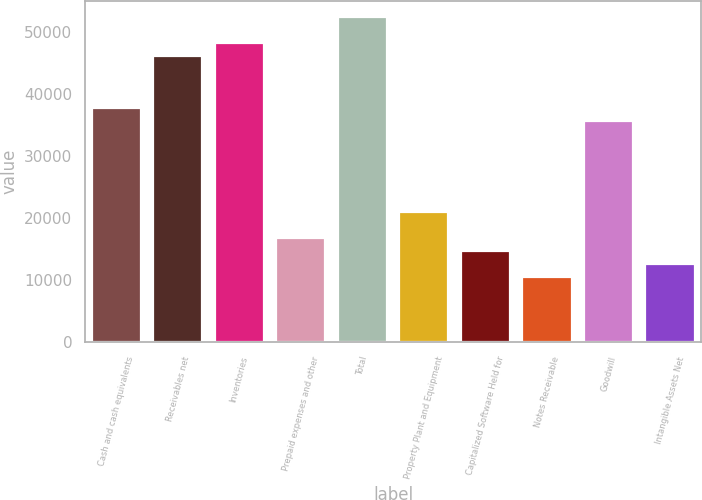<chart> <loc_0><loc_0><loc_500><loc_500><bar_chart><fcel>Cash and cash equivalents<fcel>Receivables net<fcel>Inventories<fcel>Prepaid expenses and other<fcel>Total<fcel>Property Plant and Equipment<fcel>Capitalized Software Held for<fcel>Notes Receivable<fcel>Goodwill<fcel>Intangible Assets Net<nl><fcel>37752.6<fcel>46141.4<fcel>48238.6<fcel>16780.6<fcel>52433<fcel>20975<fcel>14683.4<fcel>10489<fcel>35655.4<fcel>12586.2<nl></chart> 